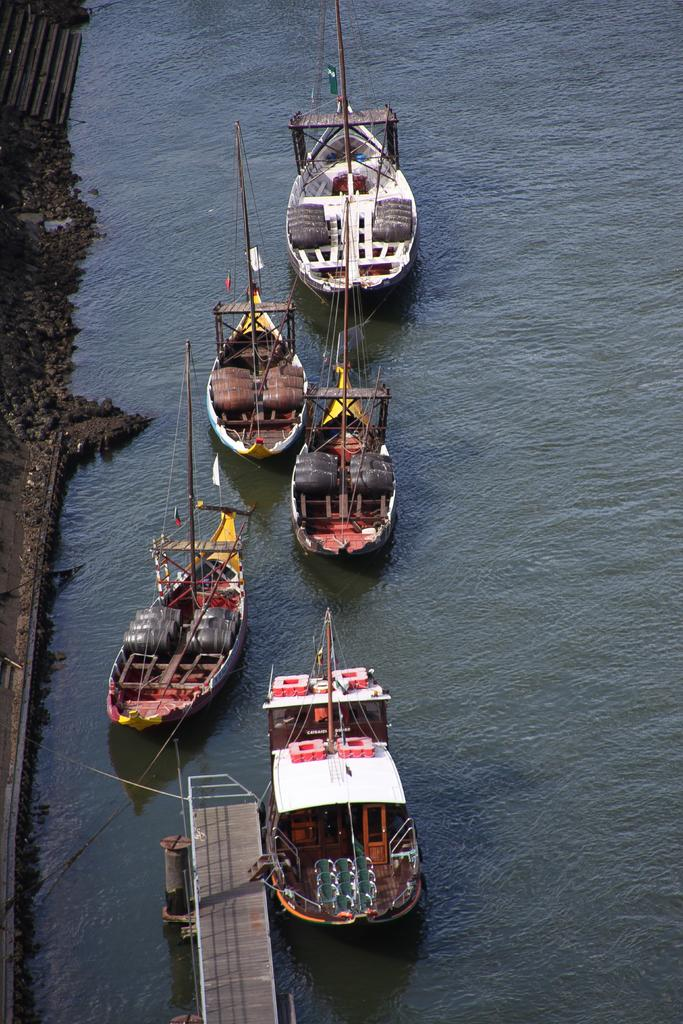What can be seen in the water in the image? There are many boats in the water. What type of structure is present in the image? There is a bridge in the image. What type of barrier is present in the image? There is fencing in the image. What can be seen on the left side of the image? There are stones and railing on the left side of the image. What architectural feature is visible in the top left of the image? There are stairs visible in the top left of the image. How many brothers are depicted in the image? There are no people, including brothers, present in the image. What advice does the expert give about the boats in the image? There is no expert present in the image to provide advice about the boats. 